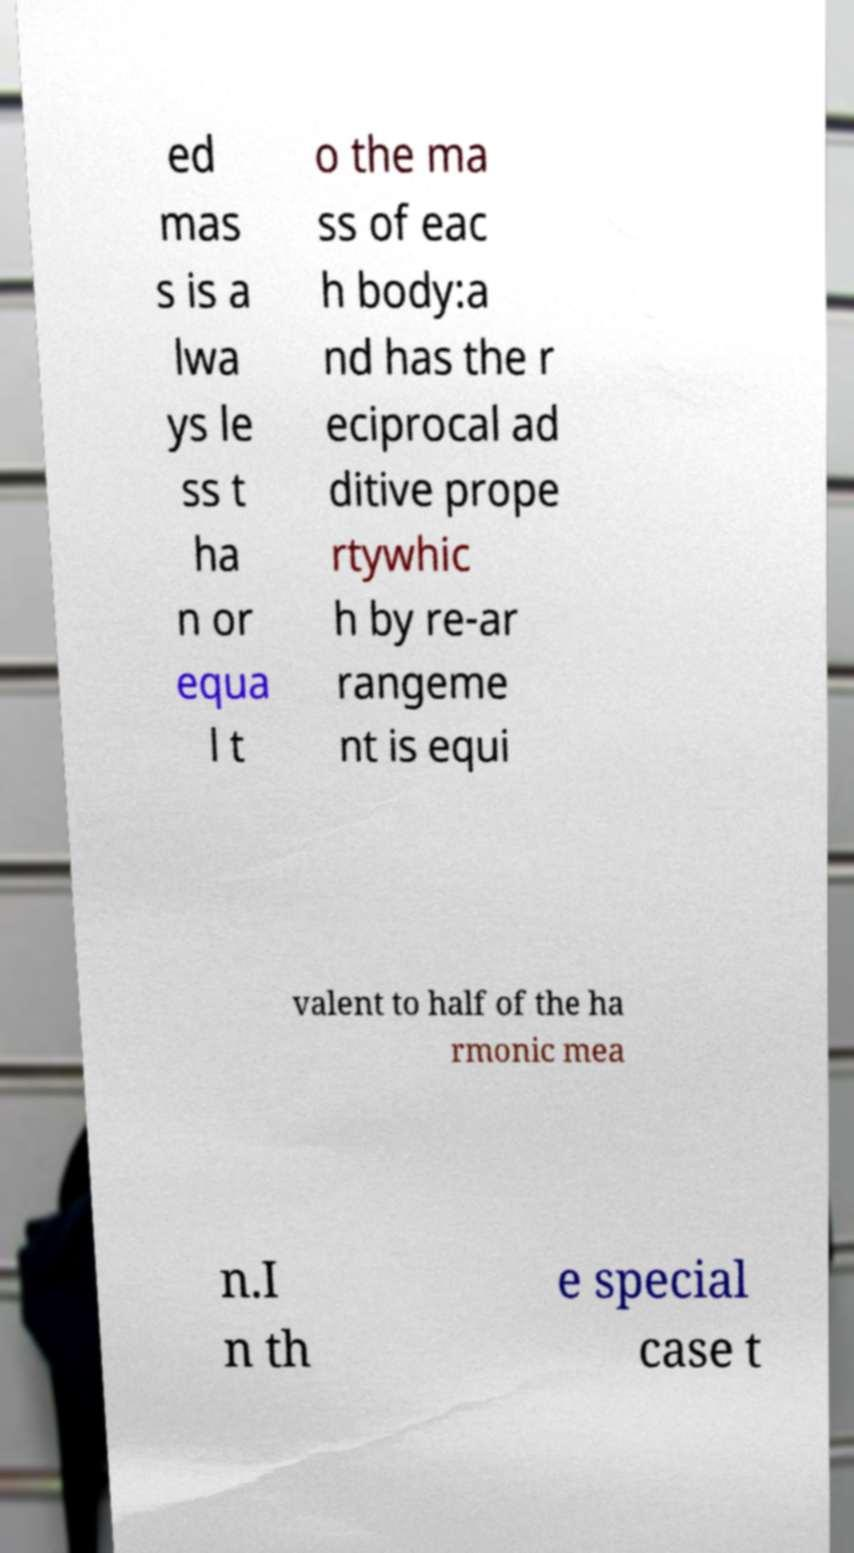Can you read and provide the text displayed in the image?This photo seems to have some interesting text. Can you extract and type it out for me? ed mas s is a lwa ys le ss t ha n or equa l t o the ma ss of eac h body:a nd has the r eciprocal ad ditive prope rtywhic h by re-ar rangeme nt is equi valent to half of the ha rmonic mea n.I n th e special case t 